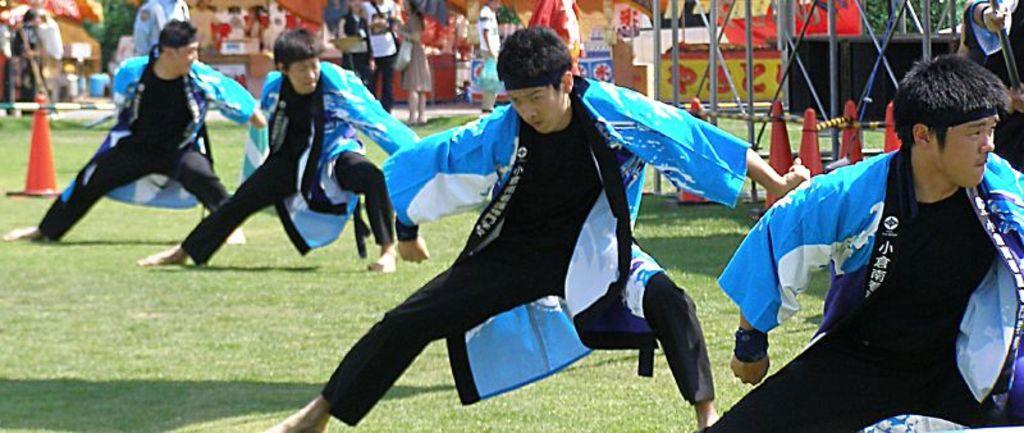How would you summarize this image in a sentence or two? In the background we can see the people, stalls and few objects. In this picture we can see the man in the same attire and same position. On the green grass we can see the traffic cones. We can see the pole, rods. On the right side of the picture we can see a person holding a black pole in the hands. 